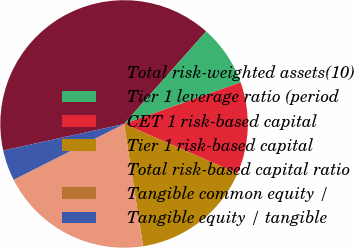<chart> <loc_0><loc_0><loc_500><loc_500><pie_chart><fcel>Total risk-weighted assets(10)<fcel>Tier 1 leverage ratio (period<fcel>CET 1 risk-based capital<fcel>Tier 1 risk-based capital<fcel>Total risk-based capital ratio<fcel>Tangible common equity /<fcel>Tangible equity / tangible<nl><fcel>39.99%<fcel>8.0%<fcel>12.0%<fcel>16.0%<fcel>20.0%<fcel>0.0%<fcel>4.0%<nl></chart> 